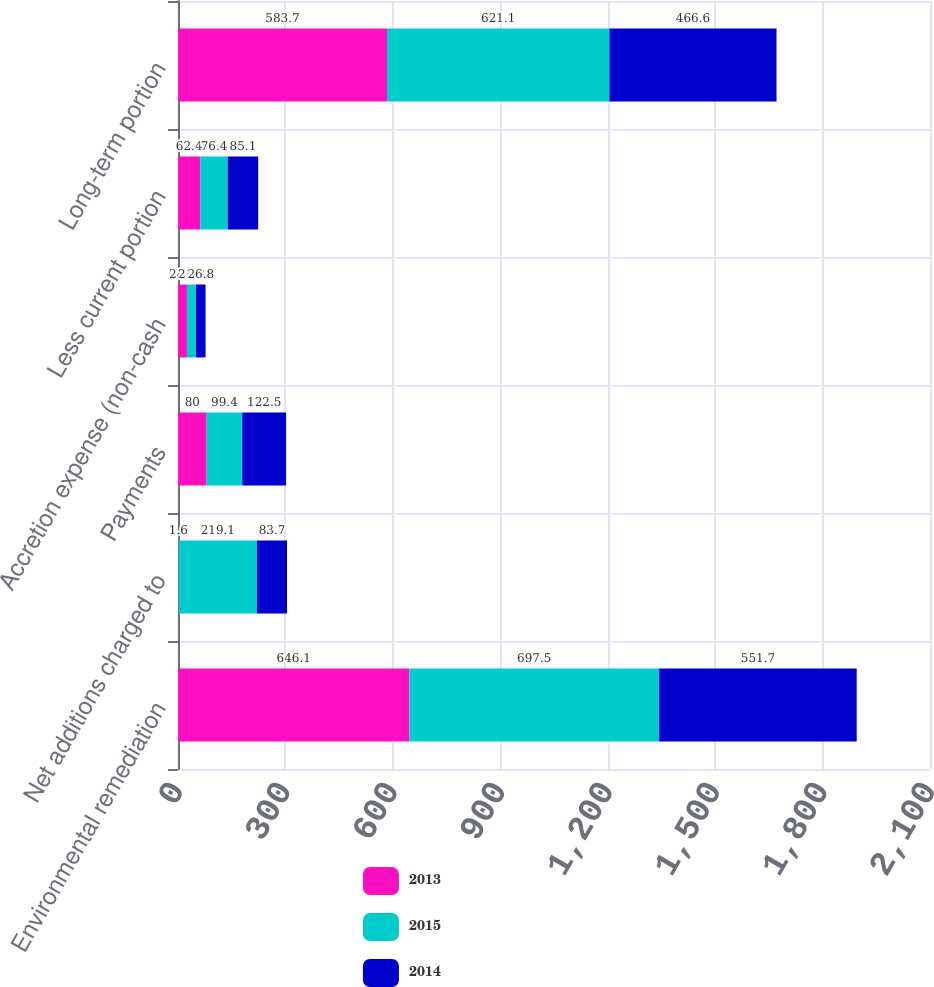Convert chart. <chart><loc_0><loc_0><loc_500><loc_500><stacked_bar_chart><ecel><fcel>Environmental remediation<fcel>Net additions charged to<fcel>Payments<fcel>Accretion expense (non-cash<fcel>Less current portion<fcel>Long-term portion<nl><fcel>2013<fcel>646.1<fcel>1.6<fcel>80<fcel>24.9<fcel>62.4<fcel>583.7<nl><fcel>2015<fcel>697.5<fcel>219.1<fcel>99.4<fcel>25.3<fcel>76.4<fcel>621.1<nl><fcel>2014<fcel>551.7<fcel>83.7<fcel>122.5<fcel>26.8<fcel>85.1<fcel>466.6<nl></chart> 